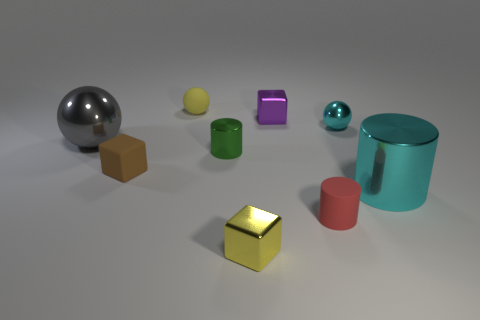Subtract all gray balls. Subtract all green blocks. How many balls are left? 2 Add 1 big spheres. How many objects exist? 10 Subtract all spheres. How many objects are left? 6 Add 8 small cyan metallic objects. How many small cyan metallic objects exist? 9 Subtract 0 red balls. How many objects are left? 9 Subtract all small green metallic objects. Subtract all brown matte things. How many objects are left? 7 Add 4 cyan metallic cylinders. How many cyan metallic cylinders are left? 5 